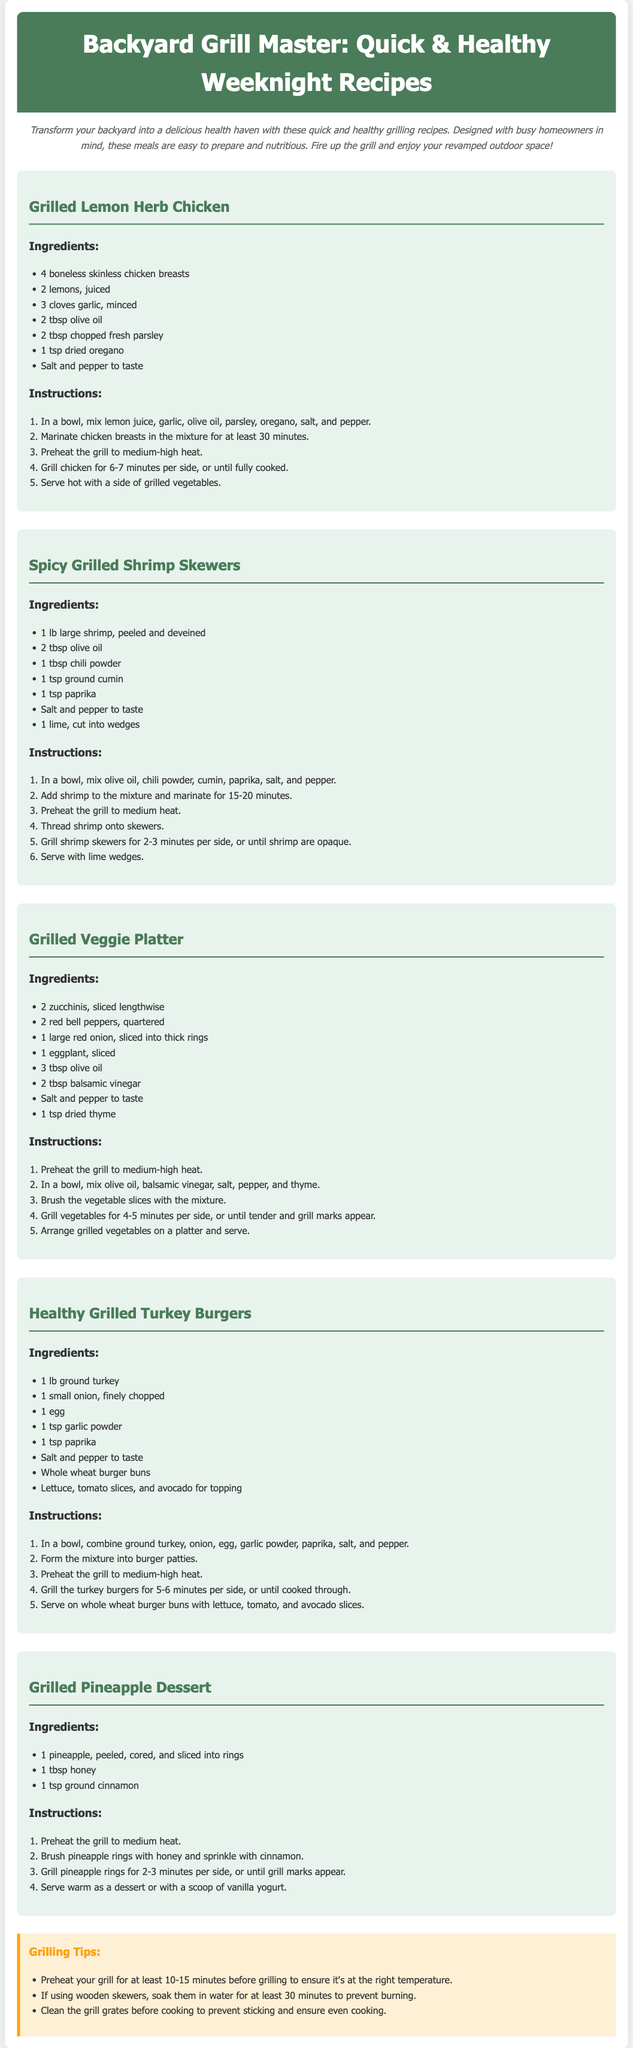what is the title of the document? The title is prominently displayed at the top of the document.
Answer: Backyard Grill Master: Quick & Healthy Weeknight Recipes how many grilling recipes are provided in the document? The document lists five distinct grilling recipes.
Answer: 5 what ingredient is used for marinating the chicken? The marination requires lemon juice mentioned in the chicken recipe.
Answer: lemon juice what is the cooking time for the grilled shrimp skewers? The document states that shrimp skewers should be grilled for 2-3 minutes per side.
Answer: 2-3 minutes per side what vegetable is included in the grilled veggie platter? The recipe lists several vegetables including eggplant, which is part of the platter.
Answer: eggplant what type of buns are recommended for the turkey burgers? The bun type is specified in the ingredients list of the turkey burger recipe.
Answer: Whole wheat burger buns which fruit is suggested for the dessert recipe? The dessert recipe explicitly mentions the use of pineapple.
Answer: pineapple how long should the chicken breasts be marinated? The chicken needs to be marinated for at least 30 minutes according to the instructions.
Answer: 30 minutes what ingredient is used to enhance the flavor of the veggie platter? The flavor enhancement ingredient specified in the veggie recipe is balsamic vinegar.
Answer: balsamic vinegar what is the recommended action for wooden skewers before use? The document advises soaking wooden skewers in water to prevent burning.
Answer: soak them in water 